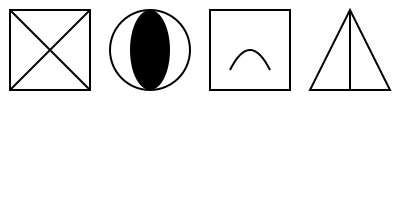Based on the pictograms shown, which symbol represents the most immediate danger to curious kittens exploring a household? Let's analyze each pictogram to determine the potential hazards for kittens:

1. The first symbol (top left) shows a square with an "X" through it. This typically represents a general warning or prohibition, but doesn't indicate a specific immediate danger.

2. The second symbol (top center) depicts an oval shape with a dark center. This likely represents a small object or pill, which could be a choking hazard or toxic if ingested by kittens.

3. The third symbol (top right) shows a square with a curved line inside. This might represent liquid or a spill, which could be dangerous if it's a toxic substance, but not necessarily an immediate threat.

4. The fourth symbol (bottom) shows a triangle with a vertical line. This often represents sharp objects or edges, which could cause injury to curious kittens.

Among these symbols, the one representing small objects or pills (second symbol) poses the most immediate danger to kittens. Kittens are naturally curious and prone to exploring with their mouths. Small objects or pills can be easily swallowed, leading to choking or poisoning, which can be life-threatening in a matter of minutes.

While sharp objects (fourth symbol) can also be dangerous, kittens are less likely to immediately injure themselves severely on these. The other symbols represent more general warnings or potential hazards that, while important to address, are not as immediately life-threatening as choking or poisoning hazards.
Answer: The oval shape with dark center (small object/pill symbol) 